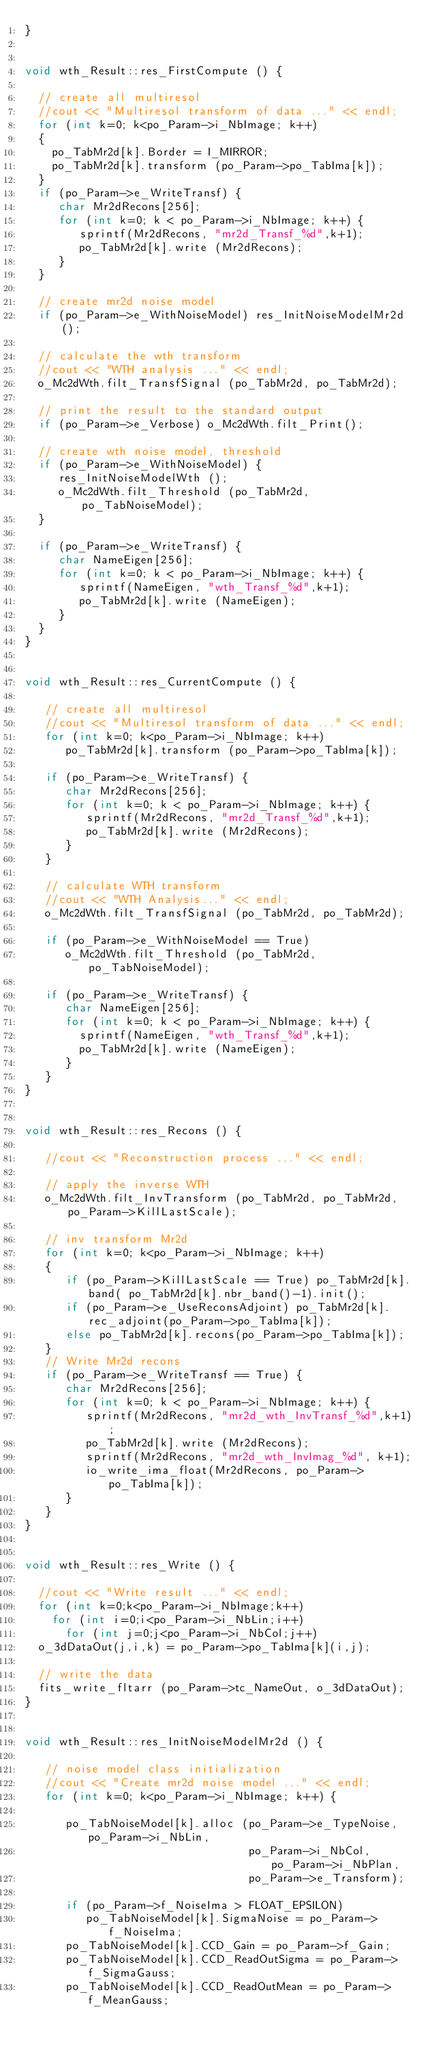<code> <loc_0><loc_0><loc_500><loc_500><_C++_>}
 
 
void wth_Result::res_FirstCompute () {

  // create all multiresol
  //cout << "Multiresol transform of data ..." << endl;
  for (int k=0; k<po_Param->i_NbImage; k++)
  {
    po_TabMr2d[k].Border = I_MIRROR;
    po_TabMr2d[k].transform (po_Param->po_TabIma[k]);
  }
  if (po_Param->e_WriteTransf) {
     char Mr2dRecons[256];
     for (int k=0; k < po_Param->i_NbImage; k++) {
        sprintf(Mr2dRecons, "mr2d_Transf_%d",k+1);
        po_TabMr2d[k].write (Mr2dRecons);
     } 
  }
    
  // create mr2d noise model
  if (po_Param->e_WithNoiseModel) res_InitNoiseModelMr2d();
  
  // calculate the wth transform
  //cout << "WTH analysis ..." << endl;
  o_Mc2dWth.filt_TransfSignal (po_TabMr2d, po_TabMr2d);
 
  // print the result to the standard output
  if (po_Param->e_Verbose) o_Mc2dWth.filt_Print();
  
  // create wth noise model, threshold  
  if (po_Param->e_WithNoiseModel) {
     res_InitNoiseModelWth ();
     o_Mc2dWth.filt_Threshold (po_TabMr2d, po_TabNoiseModel);
  } 
   
  if (po_Param->e_WriteTransf) {
     char NameEigen[256];
     for (int k=0; k < po_Param->i_NbImage; k++) {
        sprintf(NameEigen, "wth_Transf_%d",k+1);
        po_TabMr2d[k].write (NameEigen);
     }
  }
}


void wth_Result::res_CurrentCompute () {

   // create all multiresol
   //cout << "Multiresol transform of data ..." << endl;
   for (int k=0; k<po_Param->i_NbImage; k++) 
      po_TabMr2d[k].transform (po_Param->po_TabIma[k]);
      
   if (po_Param->e_WriteTransf) {
      char Mr2dRecons[256];
      for (int k=0; k < po_Param->i_NbImage; k++) {
         sprintf(Mr2dRecons, "mr2d_Transf_%d",k+1);
         po_TabMr2d[k].write (Mr2dRecons);
      } 
   }
   
   // calculate WTH transform 
   //cout << "WTH Analysis..." << endl;
   o_Mc2dWth.filt_TransfSignal (po_TabMr2d, po_TabMr2d);
   
   if (po_Param->e_WithNoiseModel == True) 
      o_Mc2dWth.filt_Threshold (po_TabMr2d, po_TabNoiseModel); 
      	  
   if (po_Param->e_WriteTransf) {
      char NameEigen[256];
      for (int k=0; k < po_Param->i_NbImage; k++) {
        sprintf(NameEigen, "wth_Transf_%d",k+1);
        po_TabMr2d[k].write (NameEigen);
      }
   } 
}


void wth_Result::res_Recons () {

   //cout << "Reconstruction process ..." << endl;

   // apply the inverse WTH
   o_Mc2dWth.filt_InvTransform (po_TabMr2d, po_TabMr2d, po_Param->KillLastScale);
   			     		      
   // inv transform Mr2d
   for (int k=0; k<po_Param->i_NbImage; k++)
   {
      if (po_Param->KillLastScale == True) po_TabMr2d[k].band( po_TabMr2d[k].nbr_band()-1).init();
      if (po_Param->e_UseReconsAdjoint) po_TabMr2d[k].rec_adjoint(po_Param->po_TabIma[k]);
      else po_TabMr2d[k].recons(po_Param->po_TabIma[k]);
   }   
   // Write Mr2d recons
   if (po_Param->e_WriteTransf == True) {
      char Mr2dRecons[256];
      for (int k=0; k < po_Param->i_NbImage; k++) {
         sprintf(Mr2dRecons, "mr2d_wth_InvTransf_%d",k+1);
         po_TabMr2d[k].write (Mr2dRecons);
         sprintf(Mr2dRecons, "mr2d_wth_InvImag_%d", k+1);
         io_write_ima_float(Mr2dRecons, po_Param->po_TabIma[k]);
      }
   }    
}


void wth_Result::res_Write () {

  //cout << "Write result ..." << endl;
  for (int k=0;k<po_Param->i_NbImage;k++)
    for (int i=0;i<po_Param->i_NbLin;i++)
      for (int j=0;j<po_Param->i_NbCol;j++)
	o_3dDataOut(j,i,k) = po_Param->po_TabIma[k](i,j);

  // write the data
  fits_write_fltarr (po_Param->tc_NameOut, o_3dDataOut);
} 


void wth_Result::res_InitNoiseModelMr2d () {

   // noise model class initialization
   //cout << "Create mr2d noise model ..." << endl;
   for (int k=0; k<po_Param->i_NbImage; k++) {

      po_TabNoiseModel[k].alloc (po_Param->e_TypeNoise, po_Param->i_NbLin, 
                                 po_Param->i_NbCol, po_Param->i_NbPlan,
                                 po_Param->e_Transform);

      if (po_Param->f_NoiseIma > FLOAT_EPSILON) 
         po_TabNoiseModel[k].SigmaNoise = po_Param->f_NoiseIma;
      po_TabNoiseModel[k].CCD_Gain = po_Param->f_Gain;
      po_TabNoiseModel[k].CCD_ReadOutSigma = po_Param->f_SigmaGauss;
      po_TabNoiseModel[k].CCD_ReadOutMean = po_Param->f_MeanGauss;
</code> 